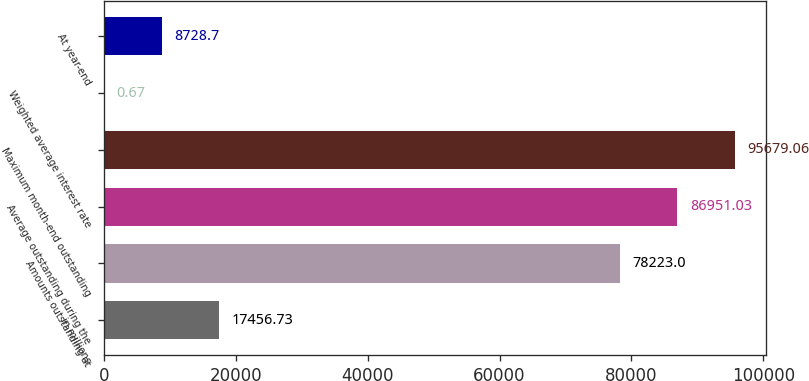Convert chart. <chart><loc_0><loc_0><loc_500><loc_500><bar_chart><fcel>in millions<fcel>Amounts outstanding at<fcel>Average outstanding during the<fcel>Maximum month-end outstanding<fcel>Weighted average interest rate<fcel>At year-end<nl><fcel>17456.7<fcel>78223<fcel>86951<fcel>95679.1<fcel>0.67<fcel>8728.7<nl></chart> 